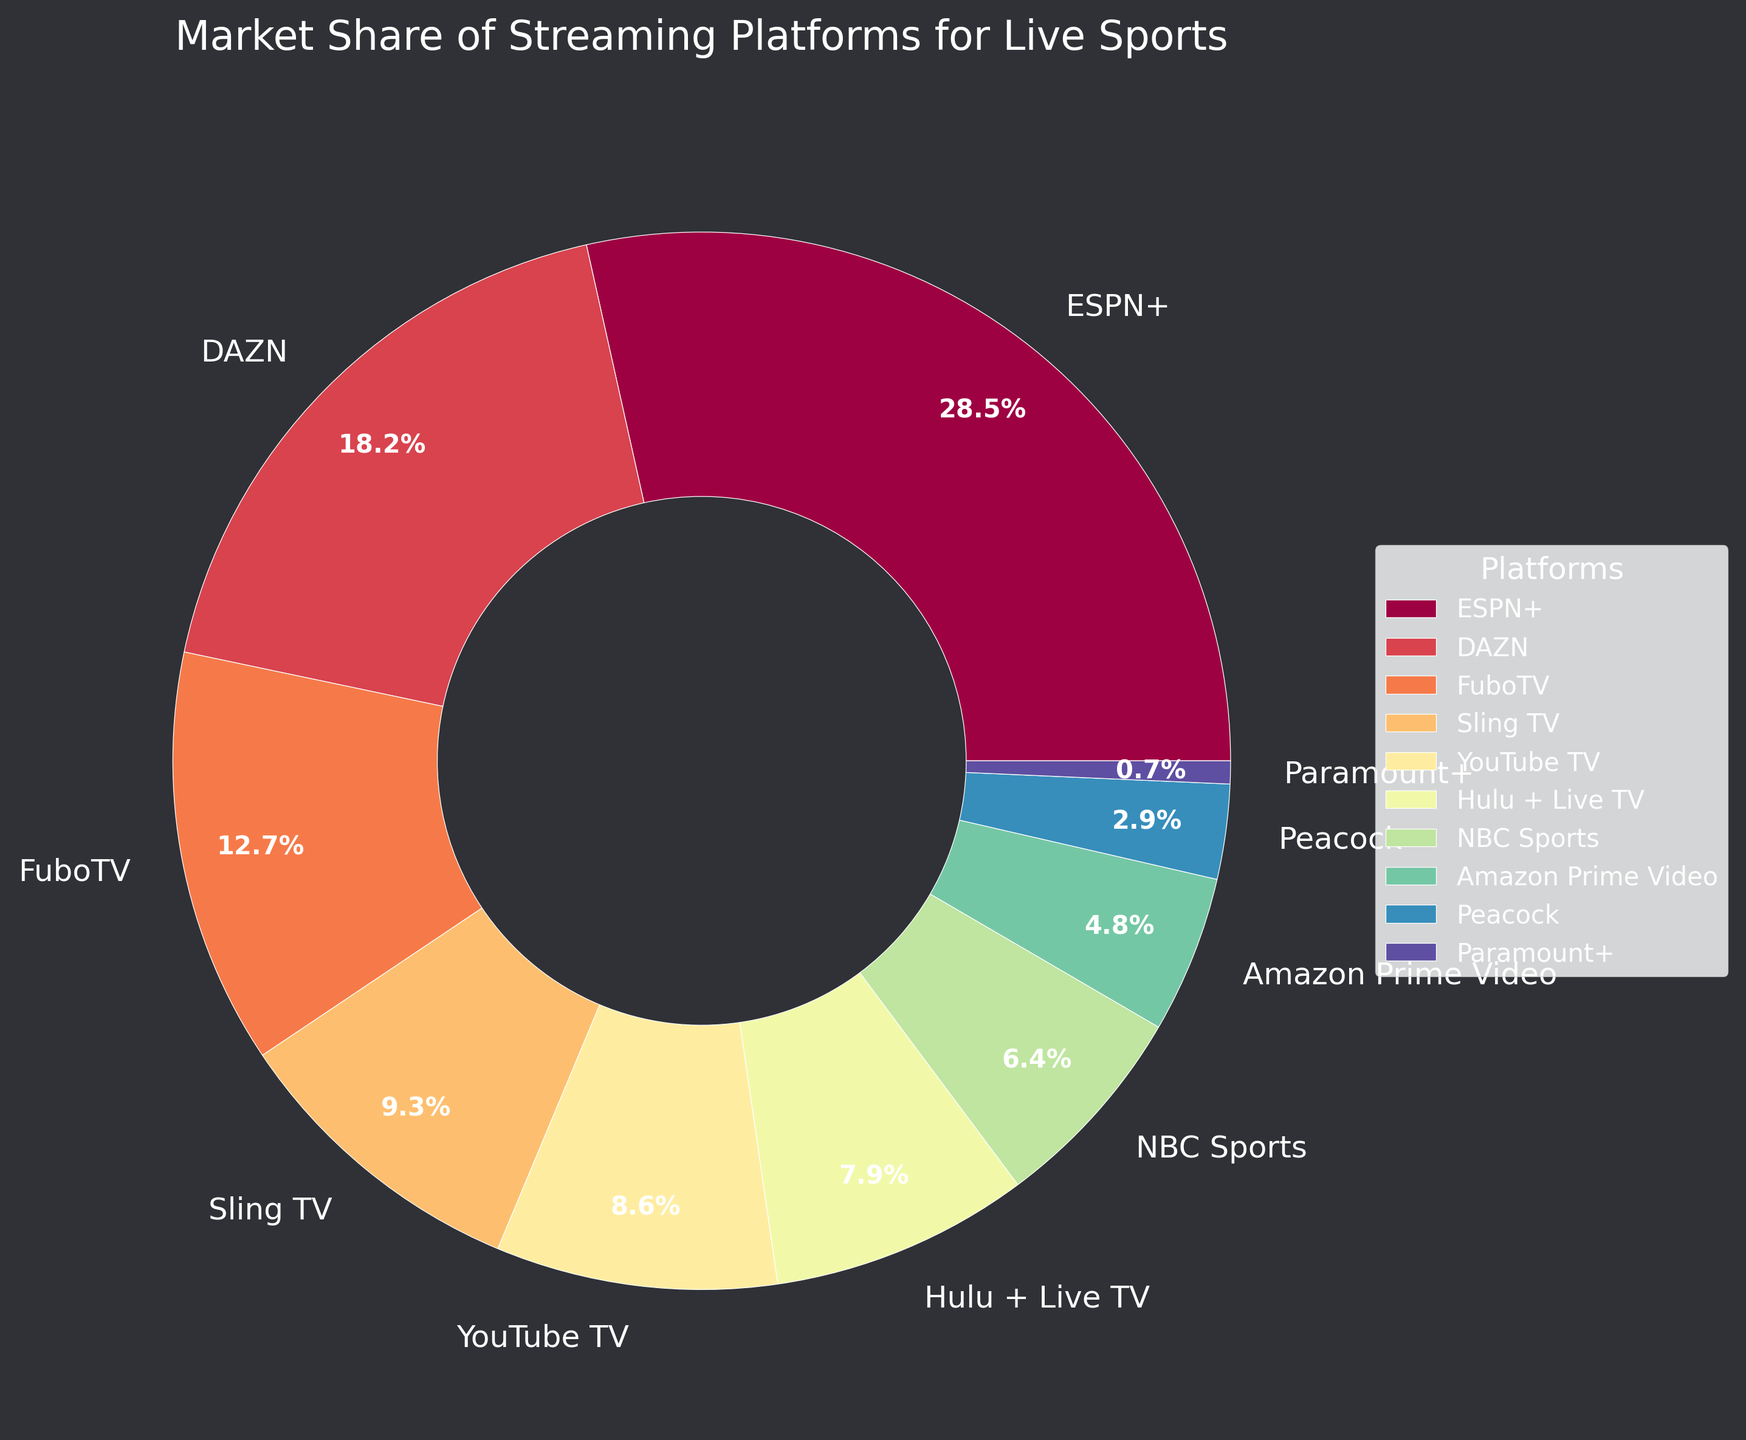Which streaming platform has the highest market share? The pie chart clearly shows that ESPN+ occupies the largest portion of the chart. This can be verified by looking at the numeric labels that denote market share percentages next to each segment.
Answer: ESPN+ What is the combined market share of Sling TV and Hulu + Live TV? From the pie chart, Sling TV has a market share of 9.3%, and Hulu + Live TV has a market share of 7.9%. Adding these together gives 9.3% + 7.9% = 17.2%.
Answer: 17.2% How much more market share does ESPN+ have compared to Amazon Prime Video? ESP+ has a market share of 28.5% while Amazon Prime Video has 4.8%. The difference is 28.5% - 4.8% = 23.7%.
Answer: 23.7% Which platform has the smallest market share and what is it? The pie chart shows that Paramount+ has the smallest slice. Its market share is labeled as 0.7%.
Answer: Paramount+, 0.7% What is the market share range of the top three streaming platforms? The top three streaming platforms by market share are ESPN+ (28.5%), DAZN (18.2%), and FuboTV (12.7%). The range is calculated as the highest percentage minus the lowest: 28.5% - 12.7% = 15.8%.
Answer: 15.8% How does the market share of YouTube TV compare to that of NBC Sports? YouTube TV has a market share of 8.6%, whereas NBC Sports has 6.4%. Comparing these, YouTube TV has a higher market share than NBC Sports.
Answer: YouTube TV has a higher market share List the platforms with a market share of less than 5%. From the pie chart, the platforms with less than 5% market share are Amazon Prime Video (4.8%), Peacock (2.9%), and Paramount+ (0.7%).
Answer: Amazon Prime Video, Peacock, Paramount+ What is the average market share of the platforms listed? To find the average, sum up all the market shares and divide by the number of platforms: (28.5 + 18.2 + 12.7 + 9.3 + 8.6 + 7.9 + 6.4 + 4.8 + 2.9 + 0.7) / 10 = 100 / 10 = 10%
Answer: 10% How much market share do the platforms in the bottom half (5 lowest shares) hold in total? Sum the market shares of the five platforms with the smallest shares: Amazon Prime Video (4.8%), Peacock (2.9%), NBC Sports (6.4%), Paramount+ (0.7%), and Hulu + Live TV (7.9%). The total is 4.8% + 2.9% + 6.4% + 0.7% + 7.9% = 22.7%.
Answer: 22.7% 